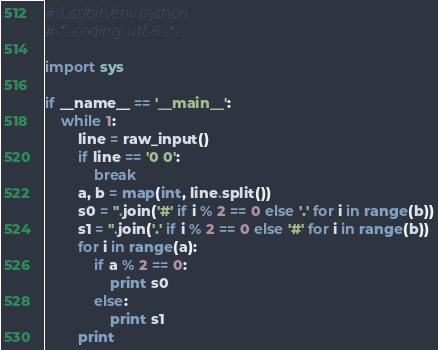Convert code to text. <code><loc_0><loc_0><loc_500><loc_500><_Python_>#!/usr/bin/env python
#-*- coding: utf-8 -*-

import sys

if __name__ == '__main__':
    while 1:
        line = raw_input()
        if line == '0 0':
            break
        a, b = map(int, line.split())
        s0 = ''.join('#' if i % 2 == 0 else '.' for i in range(b))
        s1 = ''.join('.' if i % 2 == 0 else '#' for i in range(b))
        for i in range(a):
            if a % 2 == 0:
                print s0
            else:
                print s1
        print

</code> 